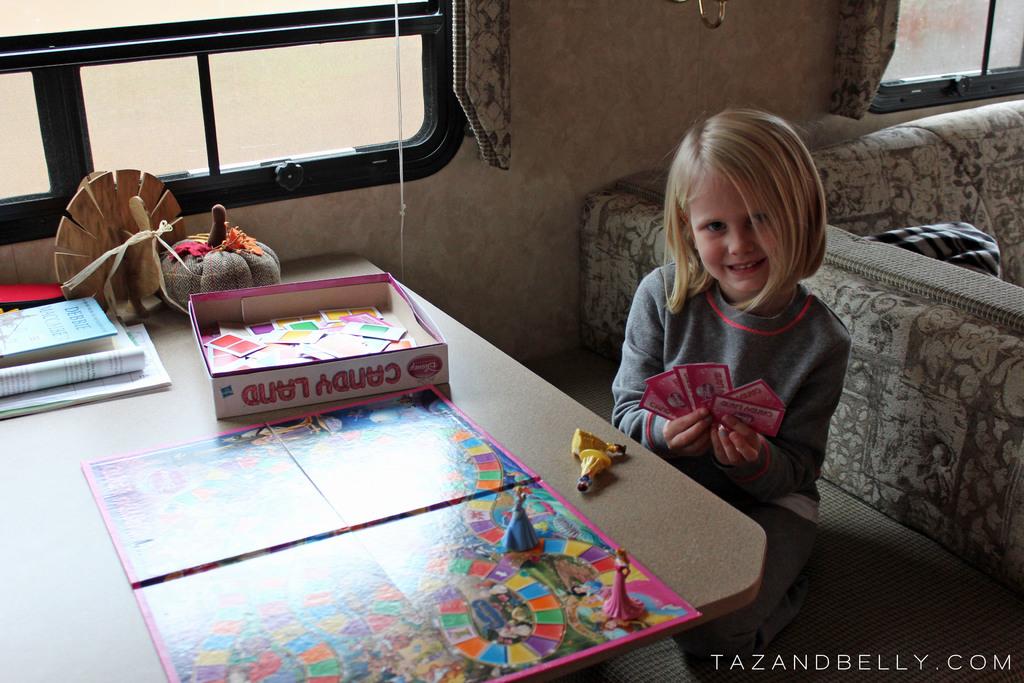What board game is she playing?
Give a very brief answer. Candy land. What website is this picture from?
Your answer should be compact. Tazandbelly.com. 